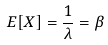<formula> <loc_0><loc_0><loc_500><loc_500>E [ X ] = \frac { 1 } { \lambda } = \beta</formula> 